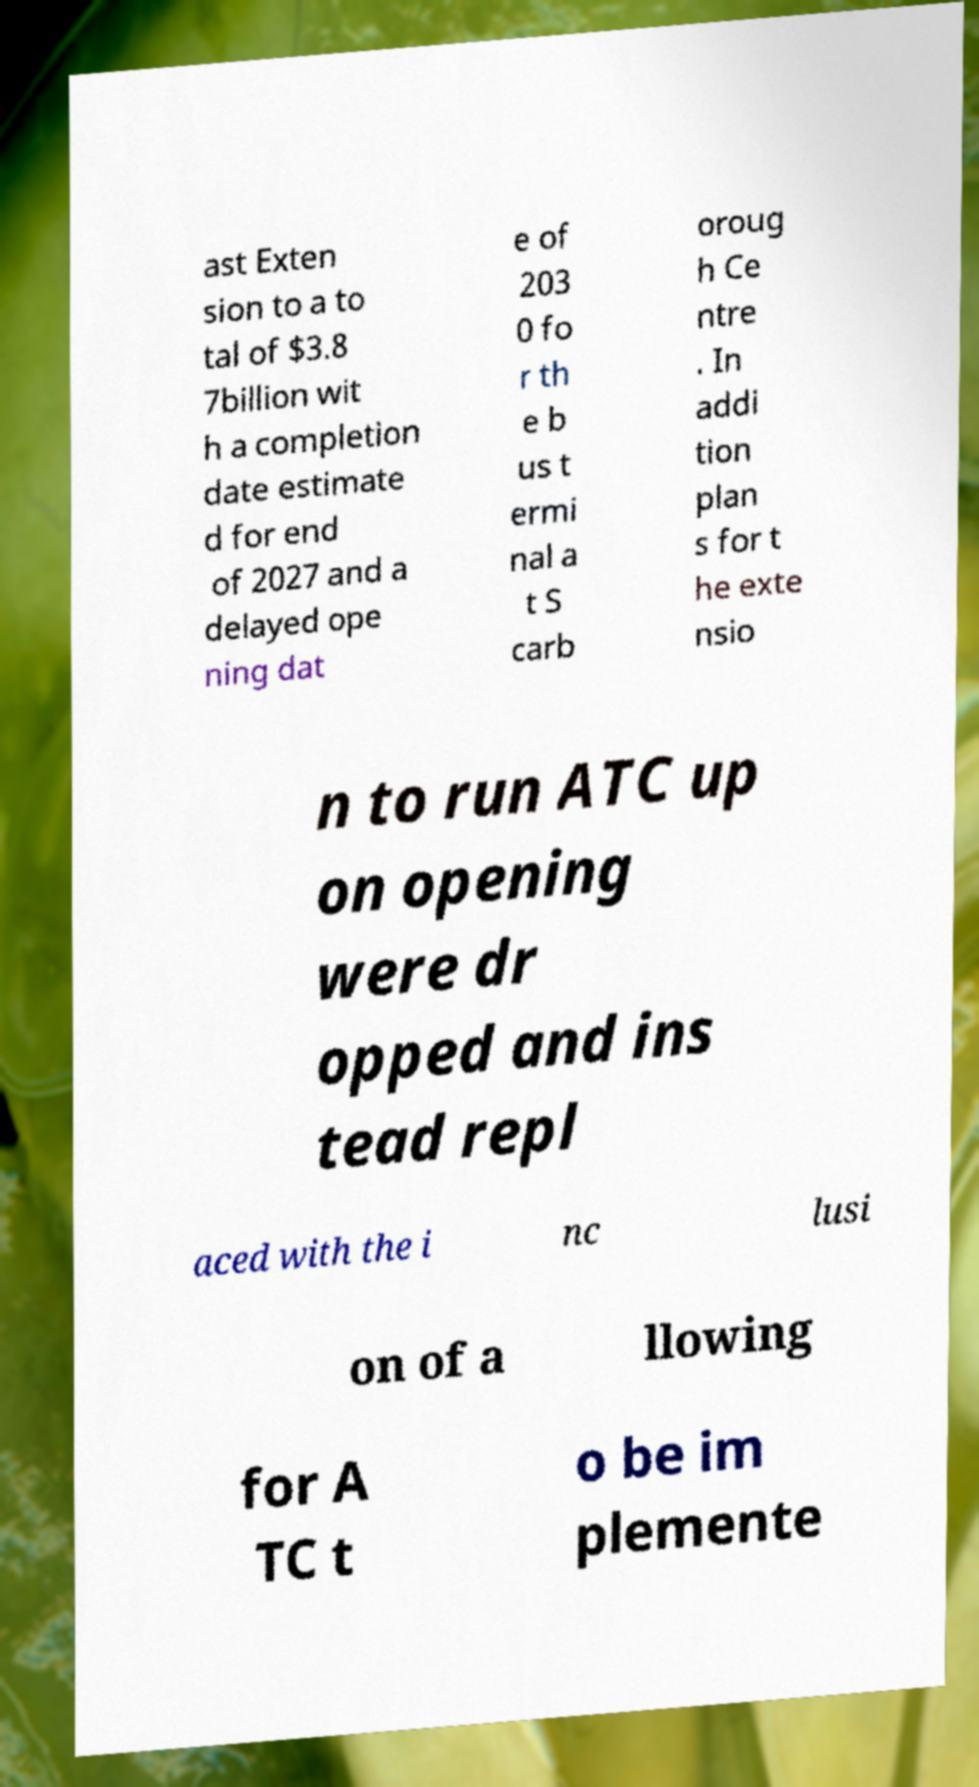There's text embedded in this image that I need extracted. Can you transcribe it verbatim? ast Exten sion to a to tal of $3.8 7billion wit h a completion date estimate d for end of 2027 and a delayed ope ning dat e of 203 0 fo r th e b us t ermi nal a t S carb oroug h Ce ntre . In addi tion plan s for t he exte nsio n to run ATC up on opening were dr opped and ins tead repl aced with the i nc lusi on of a llowing for A TC t o be im plemente 